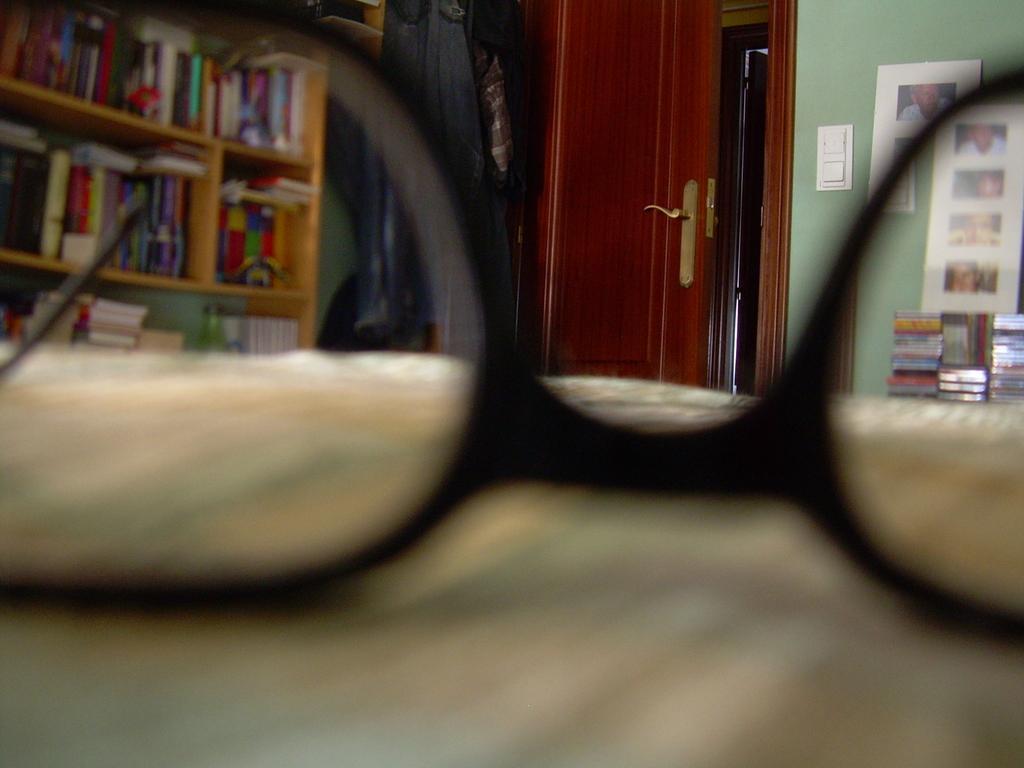Describe this image in one or two sentences. In this image in the foreground there are spectacles, and at the bottom there might be a table. And in the background there is a door, shelf and in the shelf there are books, clothes and some photos on the wall. And on the right side there are some books. 